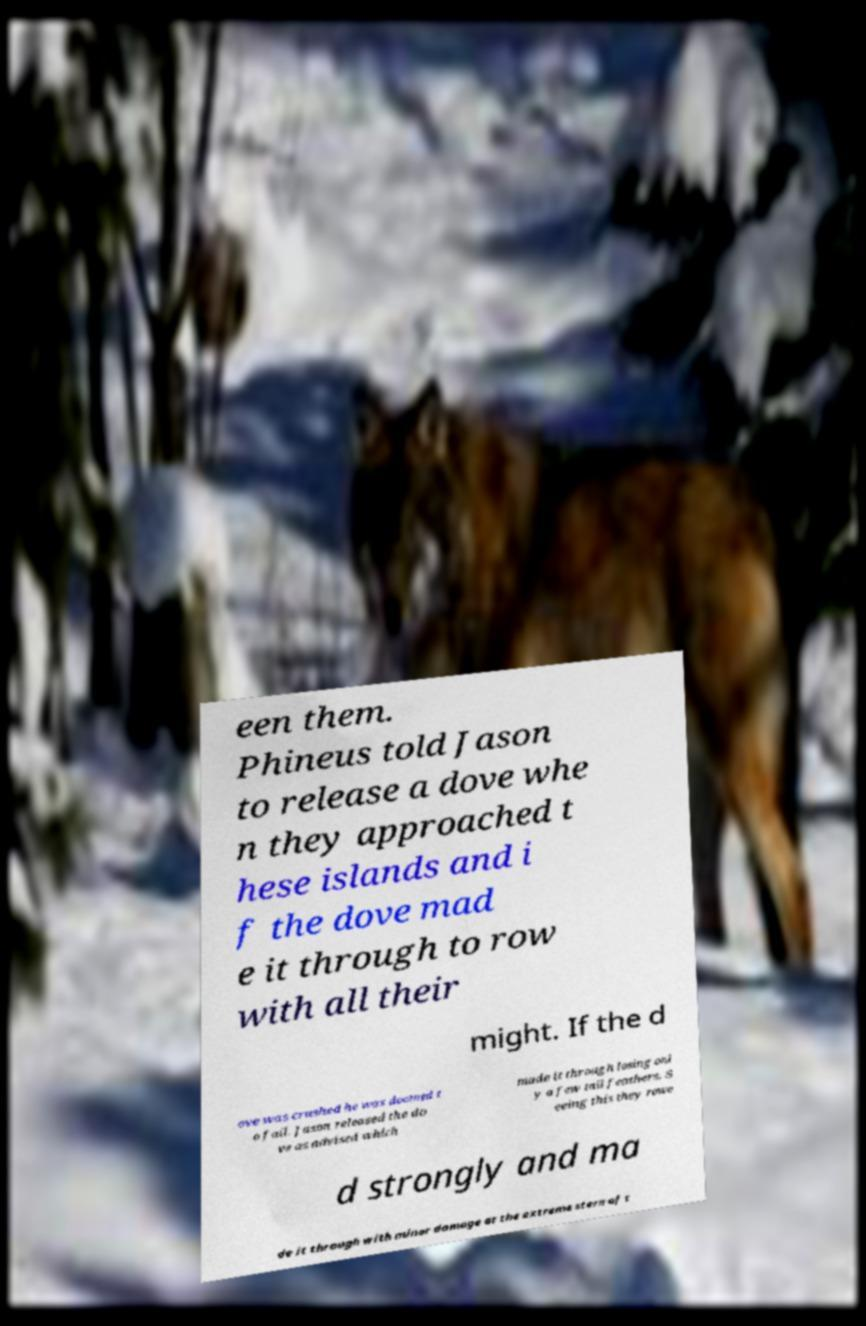Can you accurately transcribe the text from the provided image for me? een them. Phineus told Jason to release a dove whe n they approached t hese islands and i f the dove mad e it through to row with all their might. If the d ove was crushed he was doomed t o fail. Jason released the do ve as advised which made it through losing onl y a few tail feathers. S eeing this they rowe d strongly and ma de it through with minor damage at the extreme stern of t 